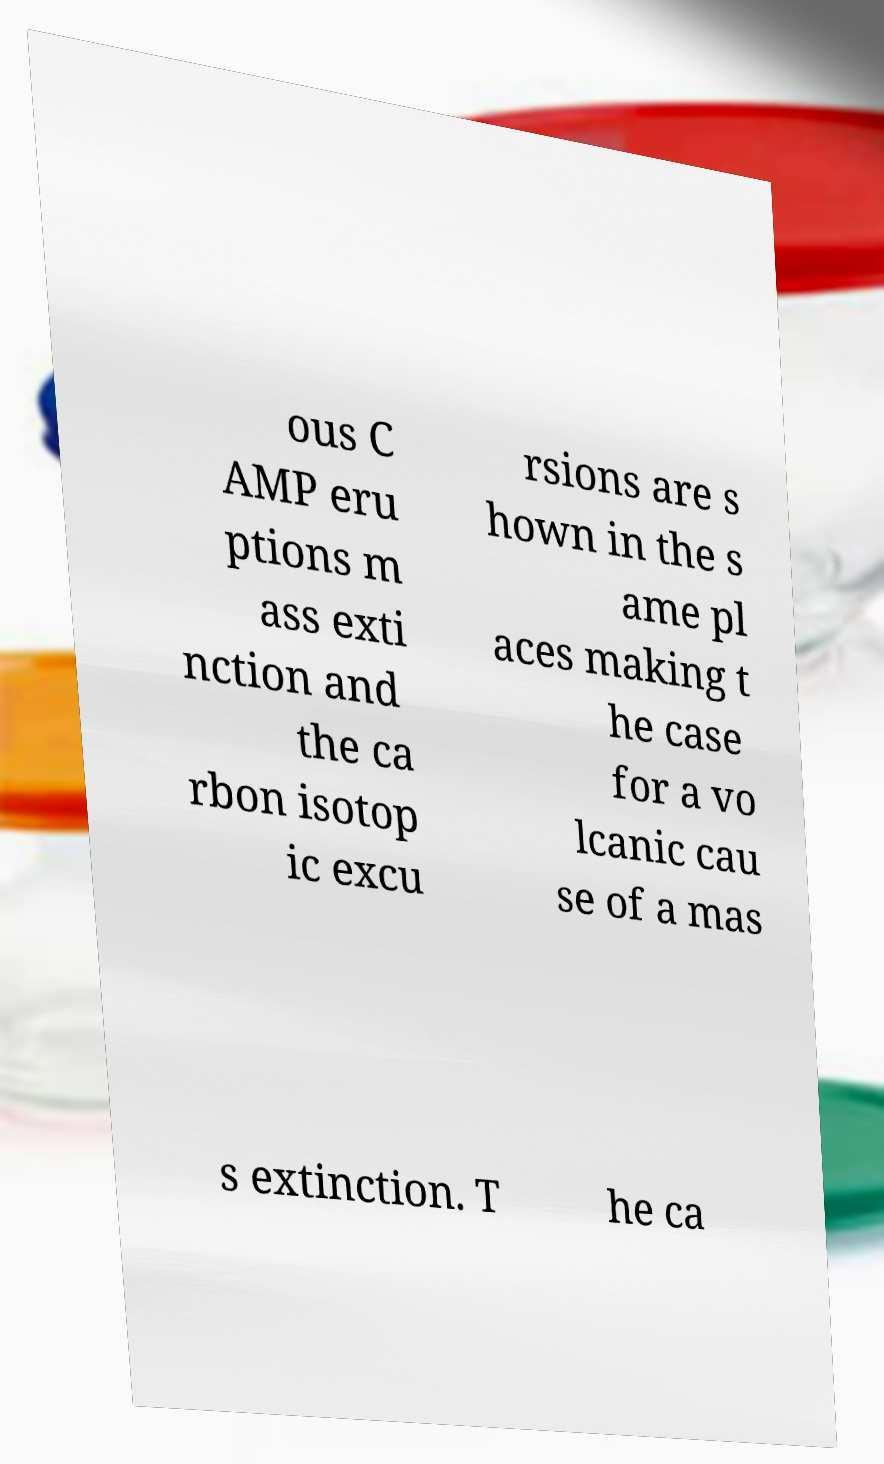Could you extract and type out the text from this image? ous C AMP eru ptions m ass exti nction and the ca rbon isotop ic excu rsions are s hown in the s ame pl aces making t he case for a vo lcanic cau se of a mas s extinction. T he ca 